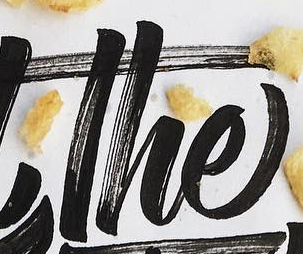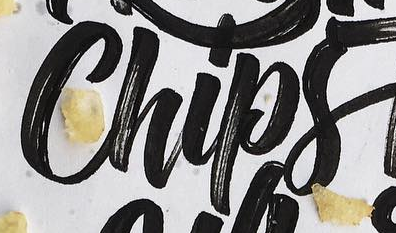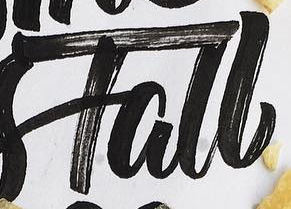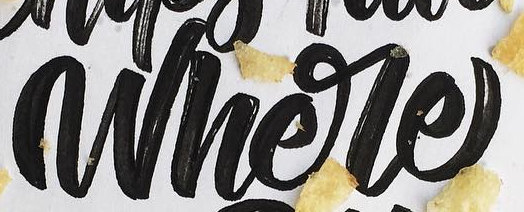Transcribe the words shown in these images in order, separated by a semicolon. The; Chips; Tall; Where 